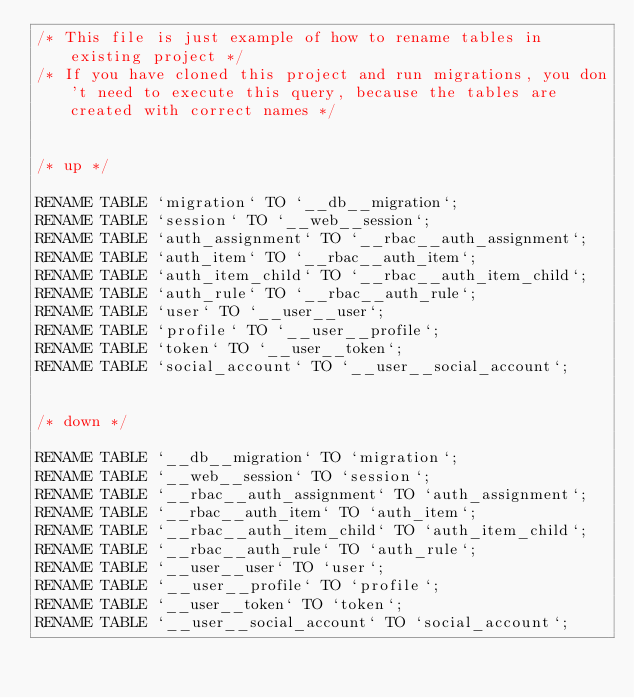<code> <loc_0><loc_0><loc_500><loc_500><_SQL_>/* This file is just example of how to rename tables in existing project */
/* If you have cloned this project and run migrations, you don't need to execute this query, because the tables are created with correct names */


/* up */

RENAME TABLE `migration` TO `__db__migration`;
RENAME TABLE `session` TO `__web__session`;
RENAME TABLE `auth_assignment` TO `__rbac__auth_assignment`;
RENAME TABLE `auth_item` TO `__rbac__auth_item`;
RENAME TABLE `auth_item_child` TO `__rbac__auth_item_child`;
RENAME TABLE `auth_rule` TO `__rbac__auth_rule`;
RENAME TABLE `user` TO `__user__user`;
RENAME TABLE `profile` TO `__user__profile`;
RENAME TABLE `token` TO `__user__token`;
RENAME TABLE `social_account` TO `__user__social_account`;


/* down */

RENAME TABLE `__db__migration` TO `migration`;
RENAME TABLE `__web__session` TO `session`;
RENAME TABLE `__rbac__auth_assignment` TO `auth_assignment`;
RENAME TABLE `__rbac__auth_item` TO `auth_item`;
RENAME TABLE `__rbac__auth_item_child` TO `auth_item_child`;
RENAME TABLE `__rbac__auth_rule` TO `auth_rule`;
RENAME TABLE `__user__user` TO `user`;
RENAME TABLE `__user__profile` TO `profile`;
RENAME TABLE `__user__token` TO `token`;
RENAME TABLE `__user__social_account` TO `social_account`;
</code> 